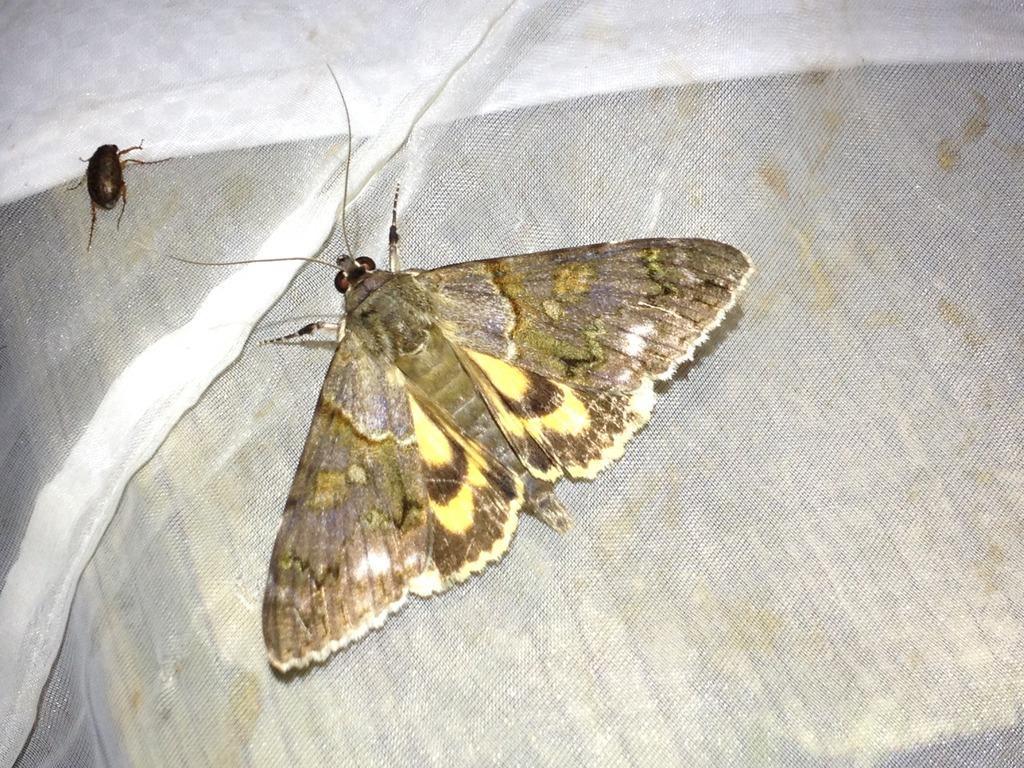How would you summarize this image in a sentence or two? In this image I can see two insects on a white cloth. 